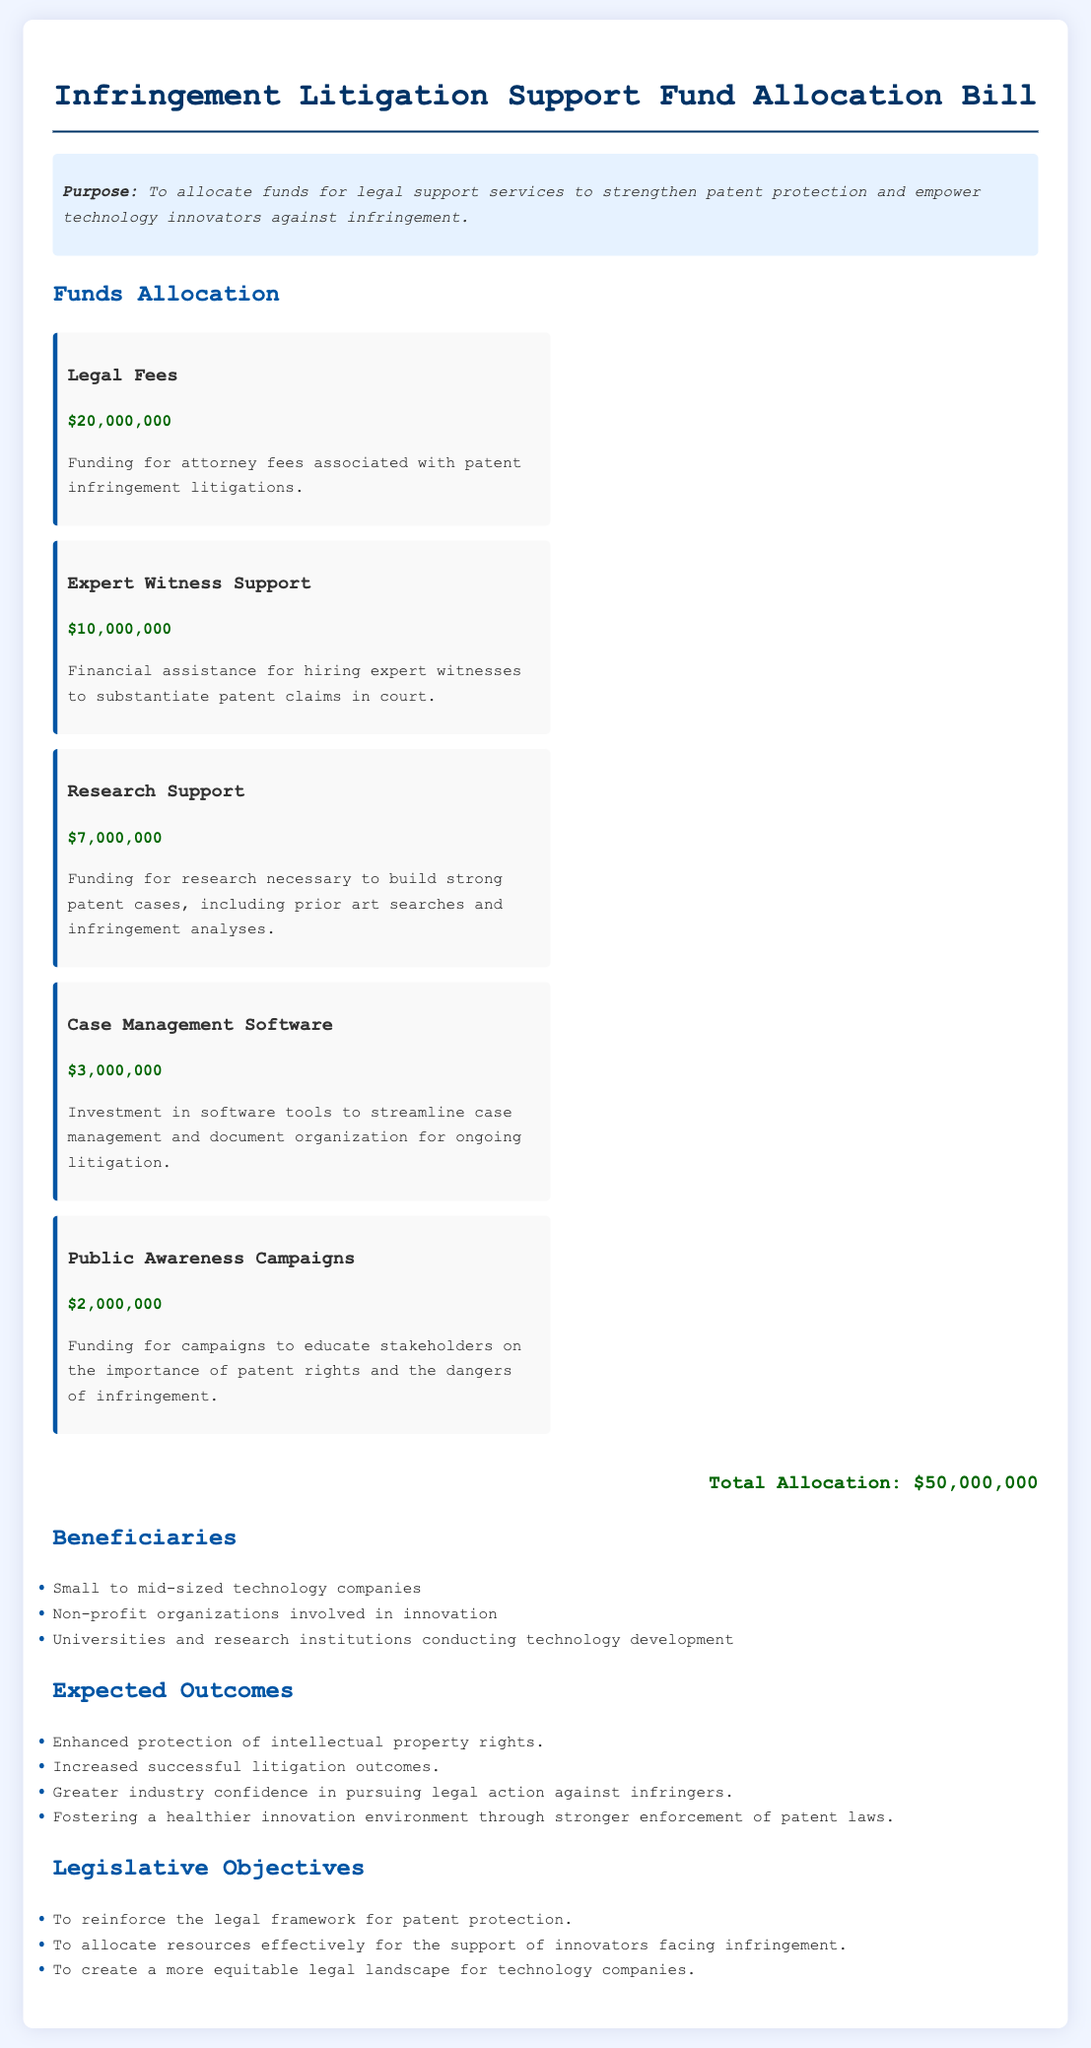What is the purpose of the bill? The purpose is to allocate funds for legal support services to strengthen patent protection and empower technology innovators against infringement.
Answer: To allocate funds for legal support services to strengthen patent protection and empower technology innovators against infringement How much is allocated for Legal Fees? The amount specifically earmarked for Legal Fees is stated in the funds allocation section of the document.
Answer: $20,000,000 What is the total amount allocated in the bill? The total allocation is shown at the end of the funds allocation section, summarizing all individual amounts.
Answer: $50,000,000 Who are the beneficiaries mentioned in the bill? The section on beneficiaries lists the groups that will benefit from the fund allocation.
Answer: Small to mid-sized technology companies, Non-profit organizations involved in innovation, Universities and research institutions conducting technology development How much funding is allocated for Research Support? The allocation for Research Support is provided in the detailed funds allocation section.
Answer: $7,000,000 Why is funding for Public Awareness Campaigns included? The rationale for including Public Awareness Campaigns involves educating stakeholders on patent rights and infringement dangers.
Answer: To educate stakeholders on the importance of patent rights and the dangers of infringement What is one expected outcome of the bill? The bill outlines several expected outcomes; one can be found in the expected outcomes section.
Answer: Enhanced protection of intellectual property rights What is the amount allocated for Case Management Software? The specific fund allocation for Case Management Software is mentioned under funds allocation.
Answer: $3,000,000 